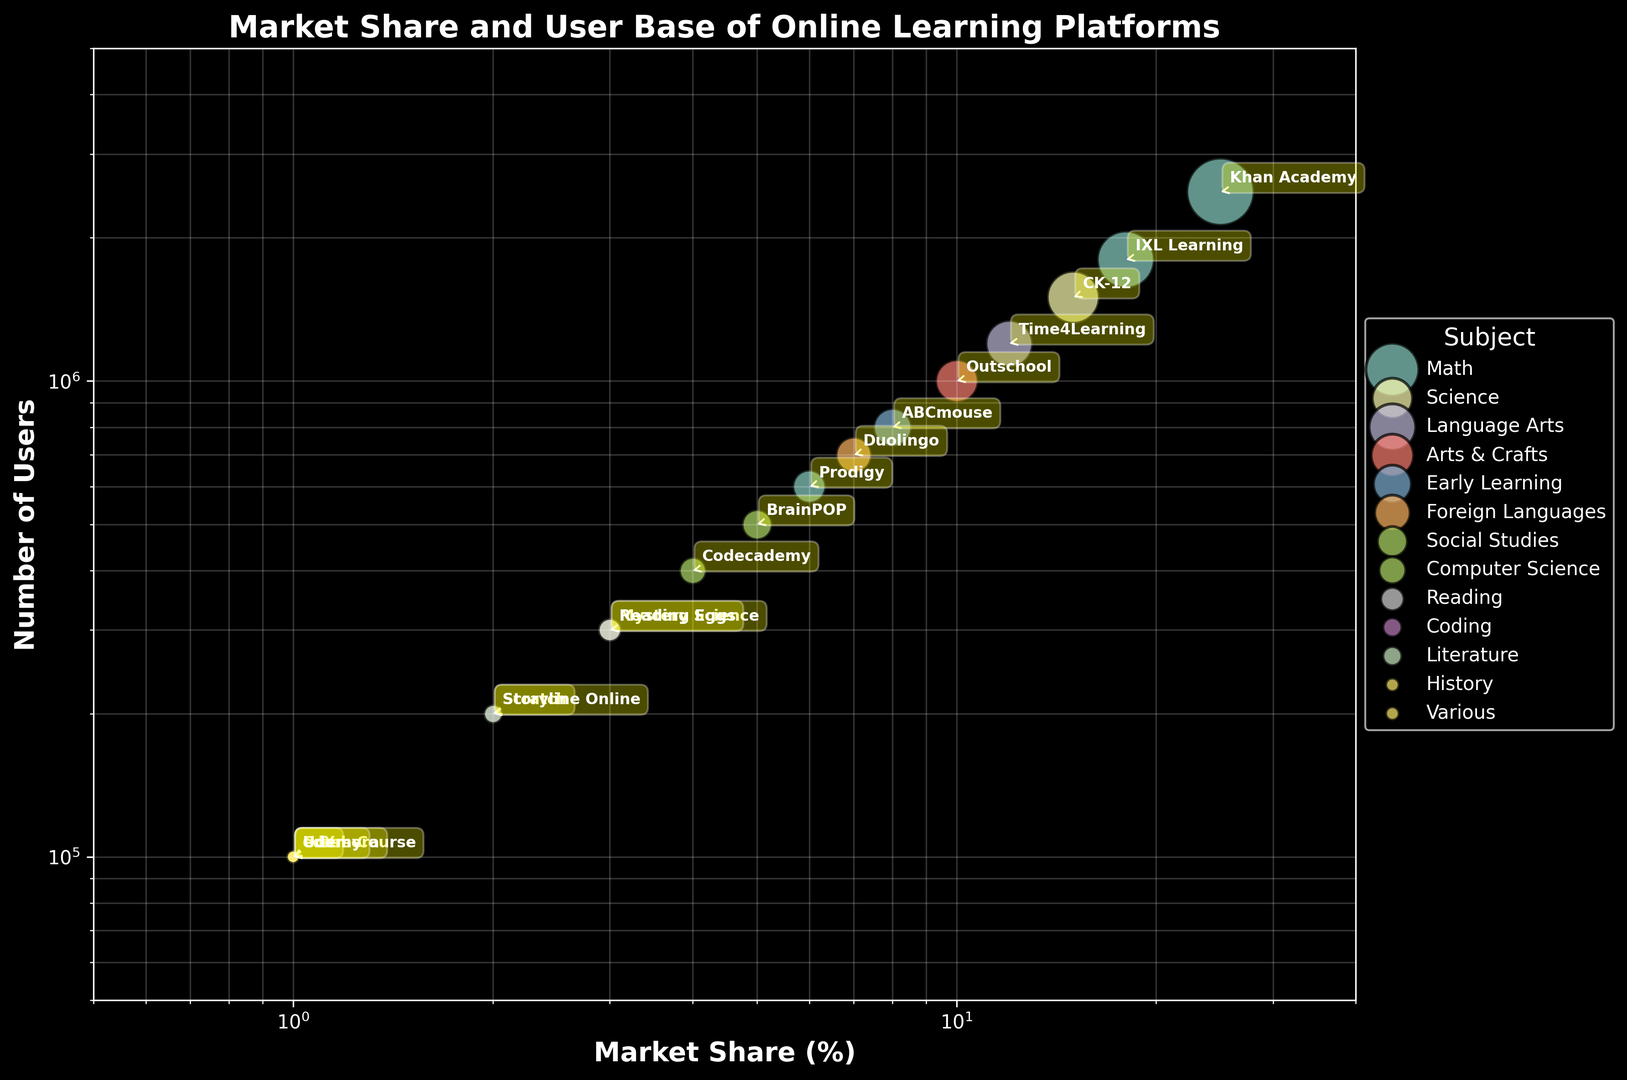What is the platform with the highest market share for Math? By observing the bubble chart, the platform with the highest market share in the Math category is the one with the largest bubble size in the Math color section. Khan Academy has the largest bubble at 25% market share in Math.
Answer: Khan Academy Which subject has the most platforms represented in the chart? Look at the legend to count how many platforms are there for each subject based on the different colored bubbles. Math has the most platforms represented (Khan Academy, IXL Learning, Prodigy)
Answer: Math How many users collectively use the Science platforms on the chart? Add the number of users for CK-12 and Mystery Science, based on the bubbles representing Science. CK-12 has 1,500,000 users, and Mystery Science has 300,000 users. 1,500,000 + 300,000 = 1,800,000 users.
Answer: 1,800,000 Which platform has a market share similar to ABCmouse? Identify the bubble marked ABCmouse with a market share of 8%, then check for other platforms with similar bubble sizes around the 8% area. Time4Learning has a market share of 12%, which is closest to 8%.
Answer: Time4Learning What’s the ratio of market share between BrainPOP and Codecademy? Locate the bubbles for BrainPOP and Codecademy, which have market shares of 5% and 4% respectively. The ratio is 5:4.
Answer: 5:4 What subject does the platform with the second highest number of users belong to? The second highest number of users is represented by IXL Learning in Math, with 1,800,000 users, after Khan Academy.
Answer: Math Compare the total market share of platforms specializing in 'Various' subjects to the total market share of platforms specializing in 'Math' subjects. Sum the market shares for 'Various' (Coursera 1%, edX 1%, Udemy 1%): 1% + 1% + 1% = 3%. Sum the market shares for 'Math' (Khan Academy 25%, IXL Learning 18%, Prodigy 6%): 25% + 18% + 6% = 49%.
Answer: Various: 3%, Math: 49% Which platform in the Language Arts subject has the highest market share, and what is it? Locate the Language Arts section, identify Time4Learning with the largest bubble in Language Arts which has a market share of 12%.
Answer: Time4Learning, 12% What is the difference in user numbers between 'Duolingo' and 'Scratch'? Duolingo has 700,000 users, and Scratch has 200,000 users. Subtract 200,000 from 700,000: 700,000 - 200,000 = 500,000.
Answer: 500,000 